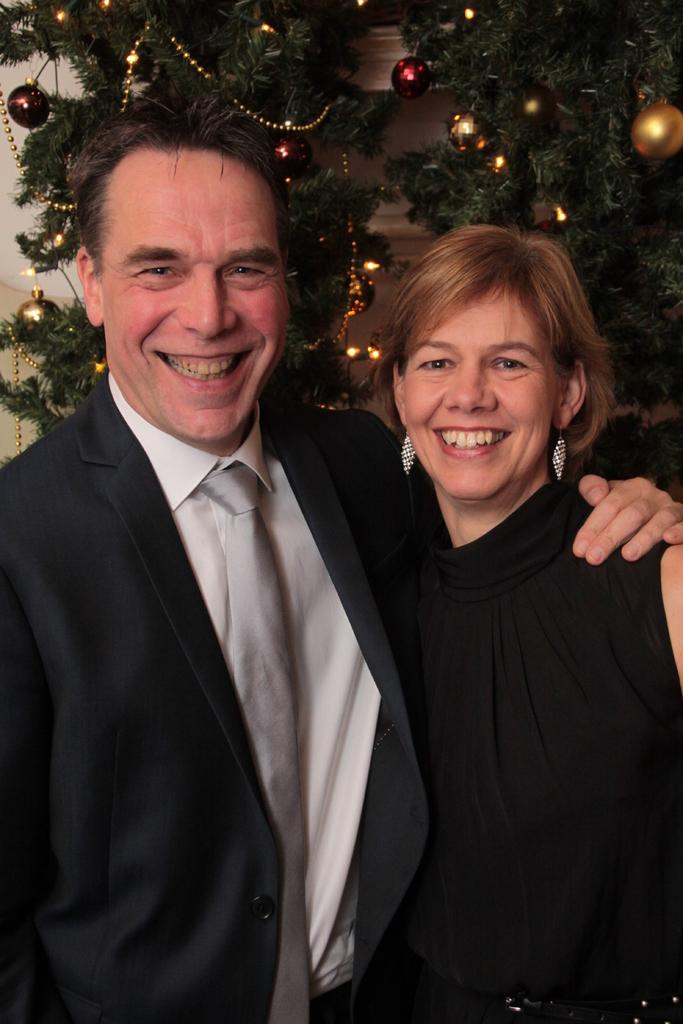Who are the people in the image? There is a man and a woman in the image. What are the man and woman doing in the image? The man and woman are standing together. What expression do they have on their faces? The man and woman are smiling. What is the main decoration in the background of the image? There is a Christmas tree in the image. Where is the Christmas tree located in the image? The Christmas tree is in front of a wall. What type of umbrella is being used to protect the man and woman from the waves in the image? There are no waves or umbrellas present in the image; it features a man and woman standing together with a Christmas tree in the background. 